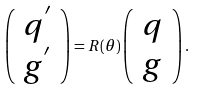Convert formula to latex. <formula><loc_0><loc_0><loc_500><loc_500>\left ( \begin{array} { c } q ^ { ^ { \prime } } \\ g ^ { ^ { \prime } } \end{array} \right ) = R ( \theta ) \left ( \begin{array} { c } q \\ g \end{array} \right ) .</formula> 